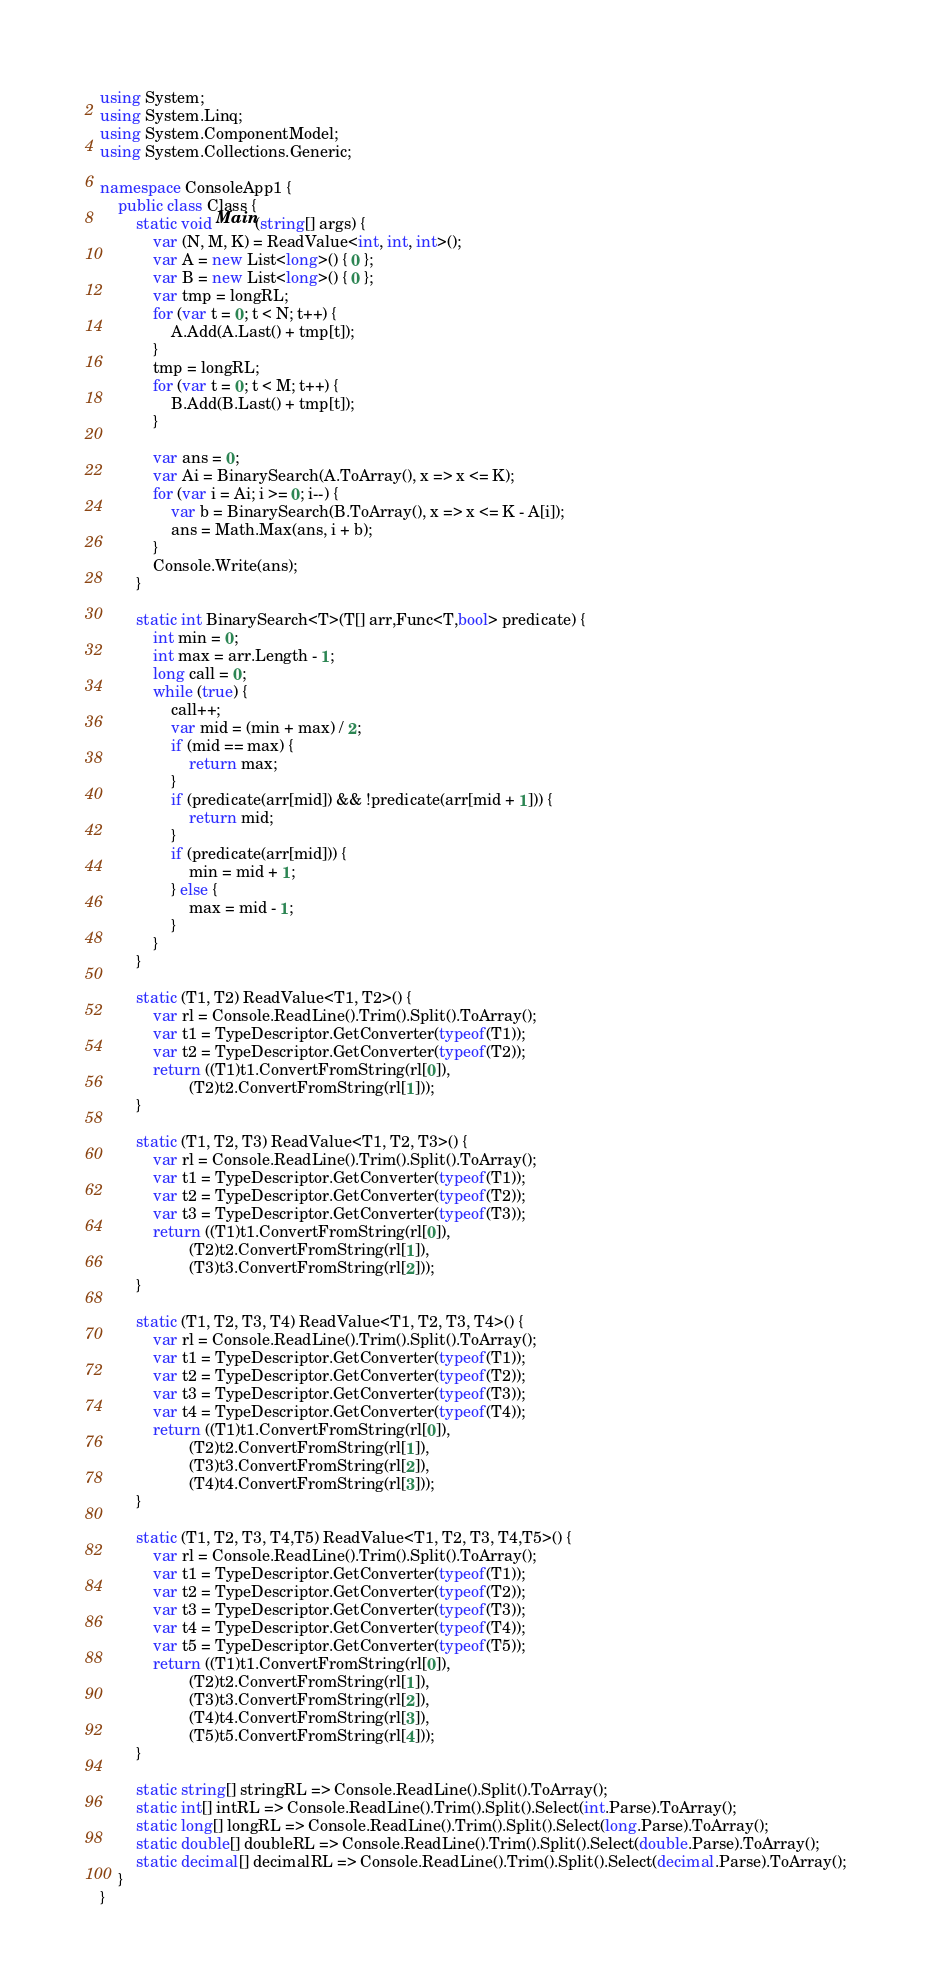<code> <loc_0><loc_0><loc_500><loc_500><_C#_>using System;
using System.Linq;
using System.ComponentModel;
using System.Collections.Generic;

namespace ConsoleApp1 {
    public class Class {
        static void Main(string[] args) {
            var (N, M, K) = ReadValue<int, int, int>();
            var A = new List<long>() { 0 };
            var B = new List<long>() { 0 };
            var tmp = longRL;
            for (var t = 0; t < N; t++) {
                A.Add(A.Last() + tmp[t]);
            }
            tmp = longRL;
            for (var t = 0; t < M; t++) {
                B.Add(B.Last() + tmp[t]);
            }

            var ans = 0;
            var Ai = BinarySearch(A.ToArray(), x => x <= K);
            for (var i = Ai; i >= 0; i--) {
                var b = BinarySearch(B.ToArray(), x => x <= K - A[i]);
                ans = Math.Max(ans, i + b);
            }
            Console.Write(ans);
        }

        static int BinarySearch<T>(T[] arr,Func<T,bool> predicate) {
            int min = 0;
            int max = arr.Length - 1;
            long call = 0;
            while (true) {
                call++;
                var mid = (min + max) / 2;
                if (mid == max) {
                    return max;
                }
                if (predicate(arr[mid]) && !predicate(arr[mid + 1])) { 
                    return mid;
                }
                if (predicate(arr[mid])) {
                    min = mid + 1;
                } else {
                    max = mid - 1;
                }
            }
        }

        static (T1, T2) ReadValue<T1, T2>() {
            var rl = Console.ReadLine().Trim().Split().ToArray();
            var t1 = TypeDescriptor.GetConverter(typeof(T1));
            var t2 = TypeDescriptor.GetConverter(typeof(T2));
            return ((T1)t1.ConvertFromString(rl[0]),
                    (T2)t2.ConvertFromString(rl[1]));
        }

        static (T1, T2, T3) ReadValue<T1, T2, T3>() {
            var rl = Console.ReadLine().Trim().Split().ToArray();
            var t1 = TypeDescriptor.GetConverter(typeof(T1));
            var t2 = TypeDescriptor.GetConverter(typeof(T2));
            var t3 = TypeDescriptor.GetConverter(typeof(T3));
            return ((T1)t1.ConvertFromString(rl[0]),
                    (T2)t2.ConvertFromString(rl[1]),
                    (T3)t3.ConvertFromString(rl[2]));
        }

        static (T1, T2, T3, T4) ReadValue<T1, T2, T3, T4>() {
            var rl = Console.ReadLine().Trim().Split().ToArray();
            var t1 = TypeDescriptor.GetConverter(typeof(T1));
            var t2 = TypeDescriptor.GetConverter(typeof(T2));
            var t3 = TypeDescriptor.GetConverter(typeof(T3));
            var t4 = TypeDescriptor.GetConverter(typeof(T4));
            return ((T1)t1.ConvertFromString(rl[0]),
                    (T2)t2.ConvertFromString(rl[1]),
                    (T3)t3.ConvertFromString(rl[2]),
                    (T4)t4.ConvertFromString(rl[3]));
        }

        static (T1, T2, T3, T4,T5) ReadValue<T1, T2, T3, T4,T5>() {
            var rl = Console.ReadLine().Trim().Split().ToArray();
            var t1 = TypeDescriptor.GetConverter(typeof(T1));
            var t2 = TypeDescriptor.GetConverter(typeof(T2));
            var t3 = TypeDescriptor.GetConverter(typeof(T3));
            var t4 = TypeDescriptor.GetConverter(typeof(T4));
            var t5 = TypeDescriptor.GetConverter(typeof(T5));
            return ((T1)t1.ConvertFromString(rl[0]),
                    (T2)t2.ConvertFromString(rl[1]),
                    (T3)t3.ConvertFromString(rl[2]),
                    (T4)t4.ConvertFromString(rl[3]),
                    (T5)t5.ConvertFromString(rl[4]));
        }

        static string[] stringRL => Console.ReadLine().Split().ToArray();
        static int[] intRL => Console.ReadLine().Trim().Split().Select(int.Parse).ToArray();
        static long[] longRL => Console.ReadLine().Trim().Split().Select(long.Parse).ToArray();
        static double[] doubleRL => Console.ReadLine().Trim().Split().Select(double.Parse).ToArray();
        static decimal[] decimalRL => Console.ReadLine().Trim().Split().Select(decimal.Parse).ToArray();
    }
}
</code> 